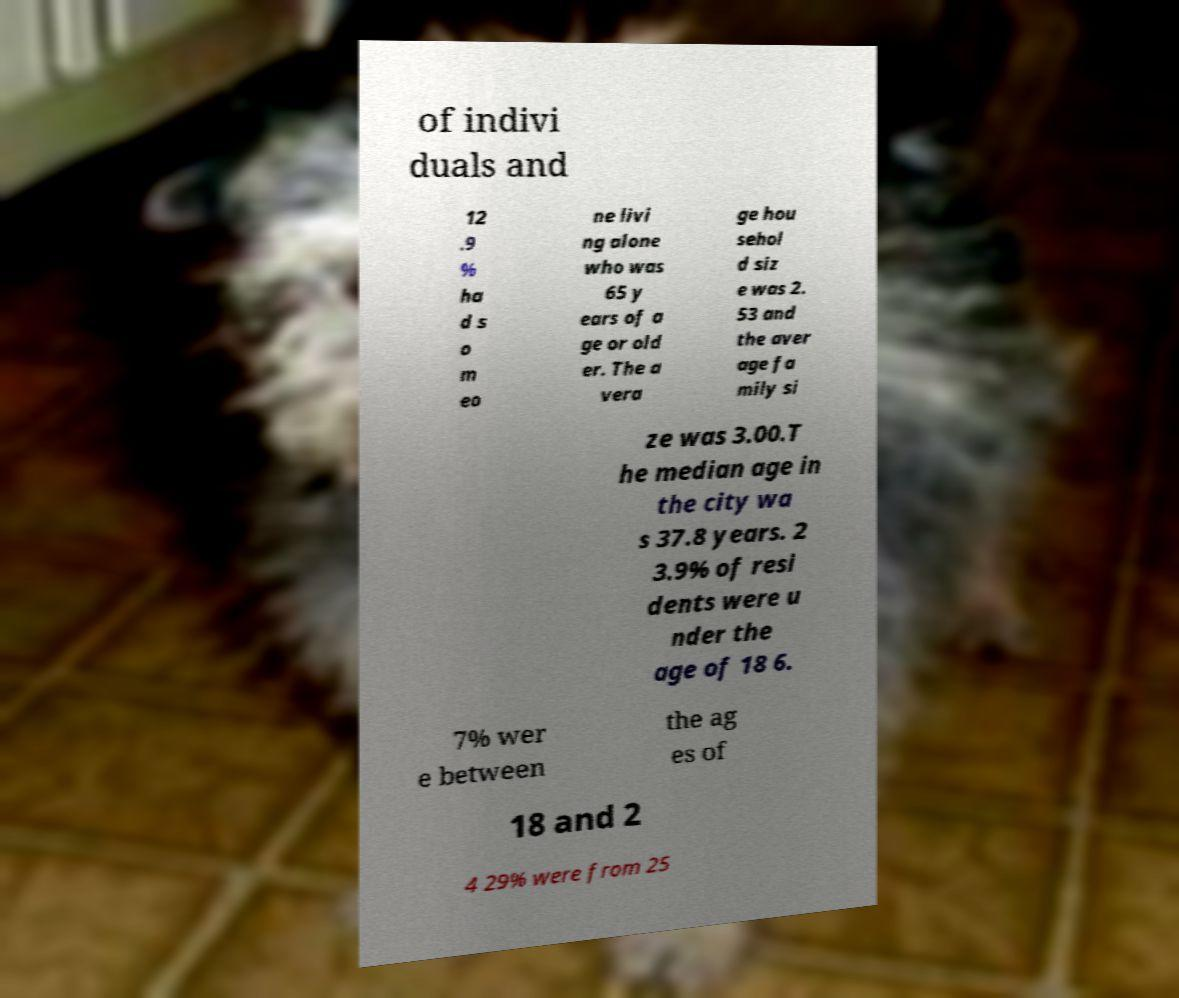I need the written content from this picture converted into text. Can you do that? of indivi duals and 12 .9 % ha d s o m eo ne livi ng alone who was 65 y ears of a ge or old er. The a vera ge hou sehol d siz e was 2. 53 and the aver age fa mily si ze was 3.00.T he median age in the city wa s 37.8 years. 2 3.9% of resi dents were u nder the age of 18 6. 7% wer e between the ag es of 18 and 2 4 29% were from 25 